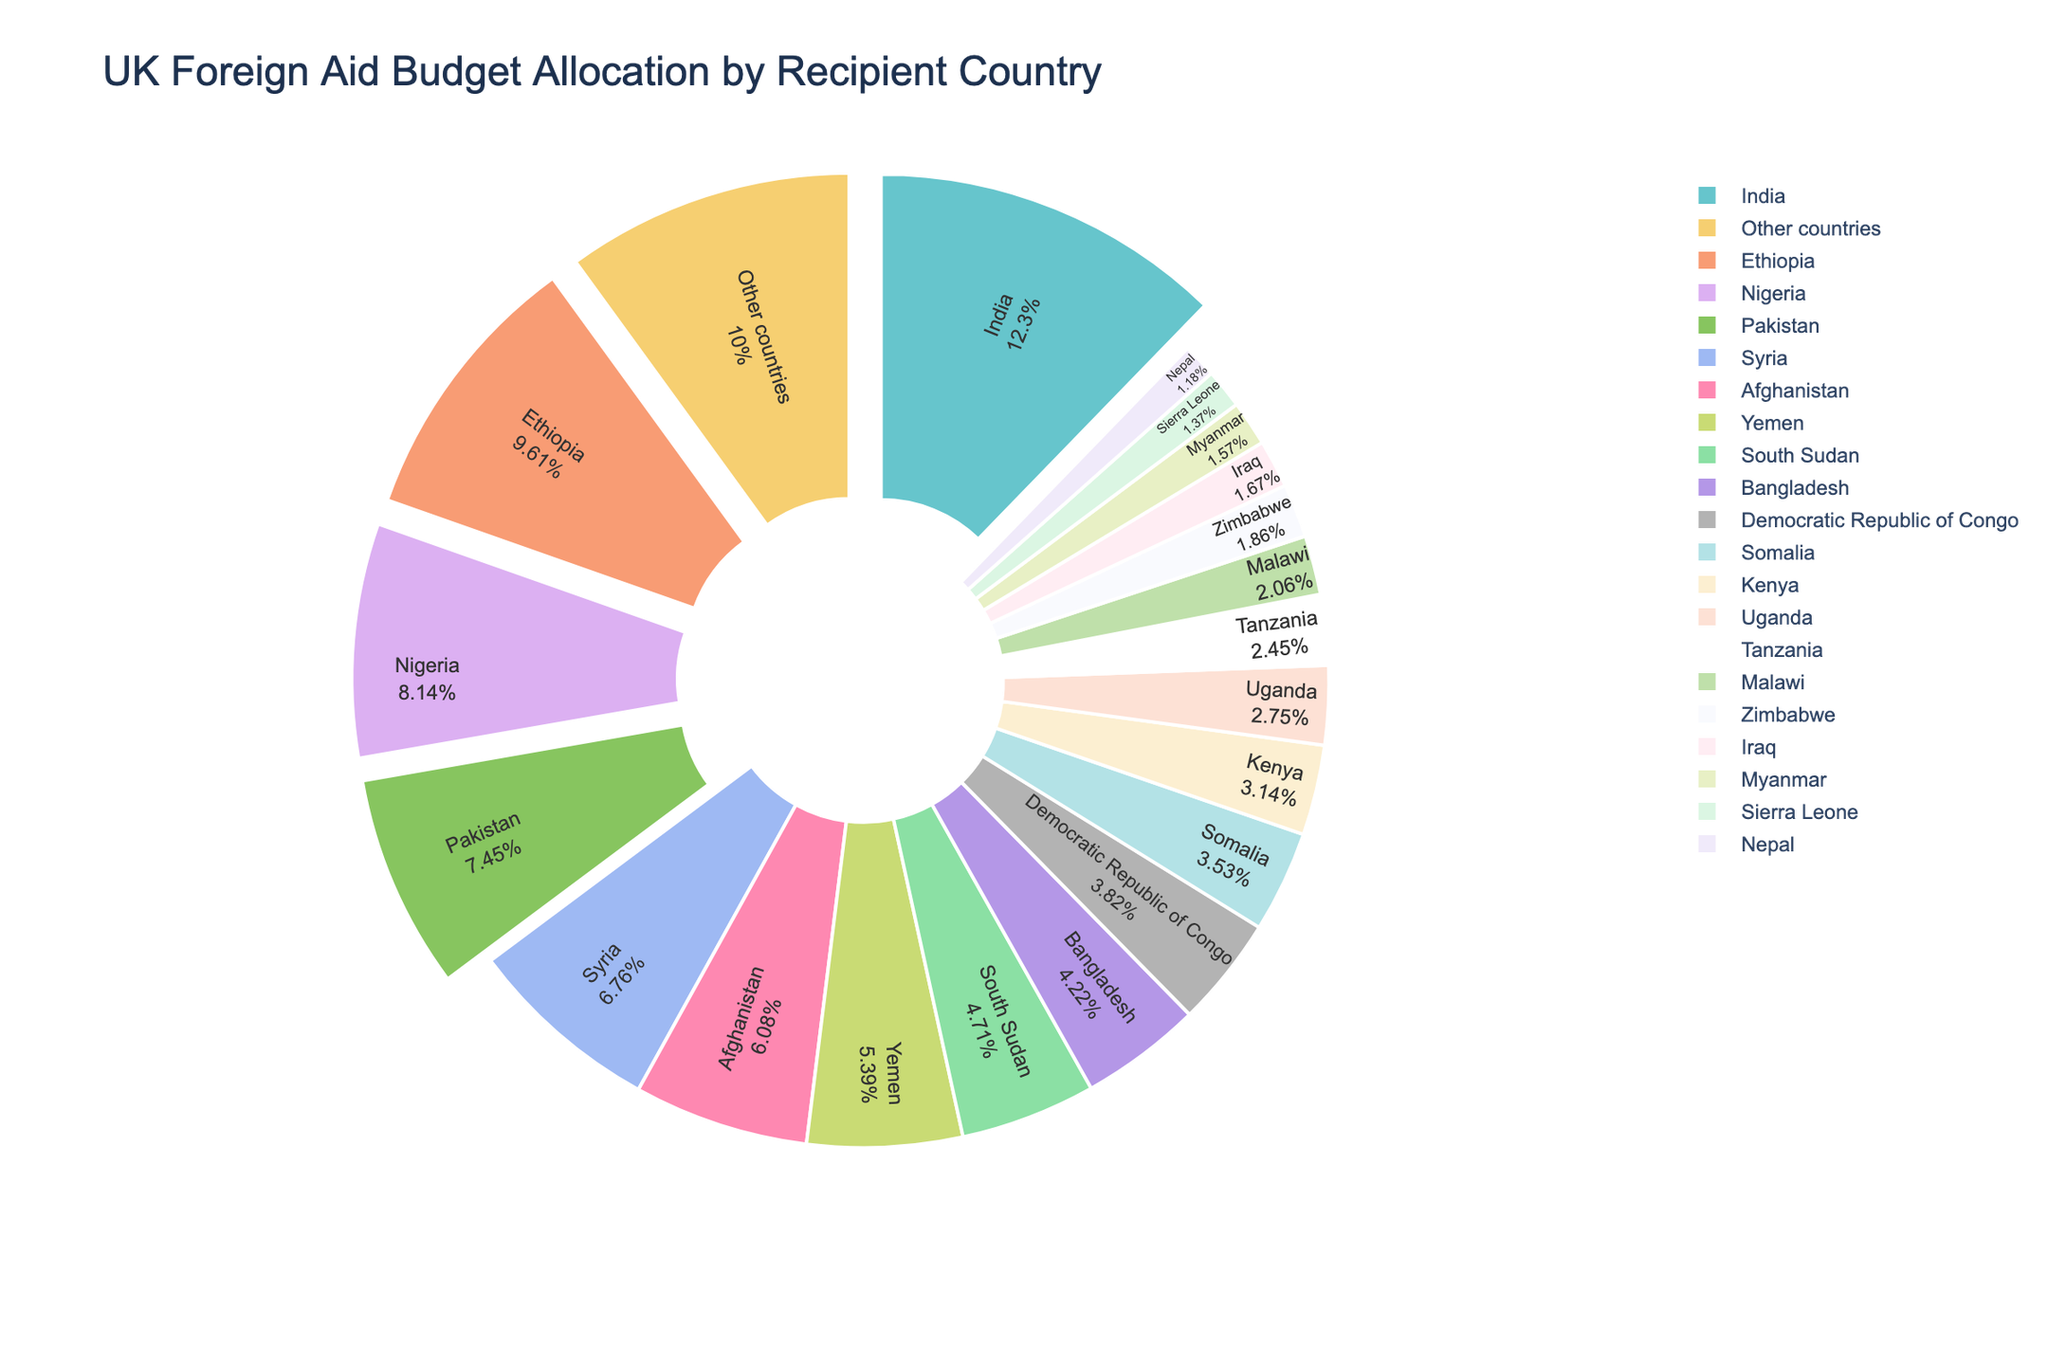Which country receives the highest foreign aid allocation? To determine the country with the highest foreign aid allocation, look for the largest wedge in the pie chart. India has the largest wedge, signifying it receives the highest allocation at 12.5%.
Answer: India Which two countries together receive the highest combined aid allocation? Identify the two largest wedges. India and Ethiopia are the two countries with the largest wedges, with allocations of 12.5% and 9.8%, respectively. Adding these percentages together gives 22.3%.
Answer: India and Ethiopia Which country receives less aid, Yemen or Bangladesh? Compare the sizes of the wedges for Yemen and Bangladesh. Yemen's wedge represents 5.5%, while Bangladesh's wedge represents 4.3%. Therefore, Bangladesh receives less aid.
Answer: Bangladesh Which countries receive aid allocations greater than 6%? Identify wedges with percentages greater than 6%. The countries with allocations greater than 6% are India (12.5%), Ethiopia (9.8%), Nigeria (8.3%), Pakistan (7.6%), and Syria (6.9%).
Answer: India, Ethiopia, Nigeria, Pakistan, Syria What is the total aid allocation for all countries receiving less than 4%? Identify wedges representing less than 4% and sum their percentages: Democratic Republic of Congo (3.9%), Somalia (3.6%), Kenya (3.2%), Uganda (2.8%), Tanzania (2.5%), Malawi (2.1%), Zimbabwe (1.9%), Iraq (1.7%), Myanmar (1.6%), Sierra Leone (1.4%), Nepal (1.2%). Adding these values gives 30.9%.
Answer: 30.9% What proportion of the total aid goes to the top five recipient countries? Identify the top five recipient countries and sum their percentages: India (12.5%), Ethiopia (9.8%), Nigeria (8.3%), Pakistan (7.6%), Syria (6.9%). Adding these values gives 45.1%.
Answer: 45.1% How does the aid allocated to Afghanistan compare to that allocated to Somalia? Compare the sizes of the wedges for Afghanistan and Somalia. Afghanistan's wedge is larger at 6.2%, while Somalia's is 3.6%, meaning Afghanistan receives more aid.
Answer: Afghanistan receives more Which country has the smallest aid allocation? Identify the smallest wedge in the pie chart. Nepal has the smallest allocation at 1.2%.
Answer: Nepal What is the combined aid allocation for South Sudan and Bangladesh? Identify the wedges for South Sudan and Bangladesh and sum their percentages: South Sudan (4.8%) and Bangladesh (4.3%). Adding these values gives 9.1%.
Answer: 9.1% How many countries receive aid allocations between 4% and 7%? Identify wedges with percentages between 4% and 7%. These countries are Syria (6.9%), Afghanistan (6.2%), Yemen (5.5%), and South Sudan (4.8%), totaling four countries.
Answer: 4 